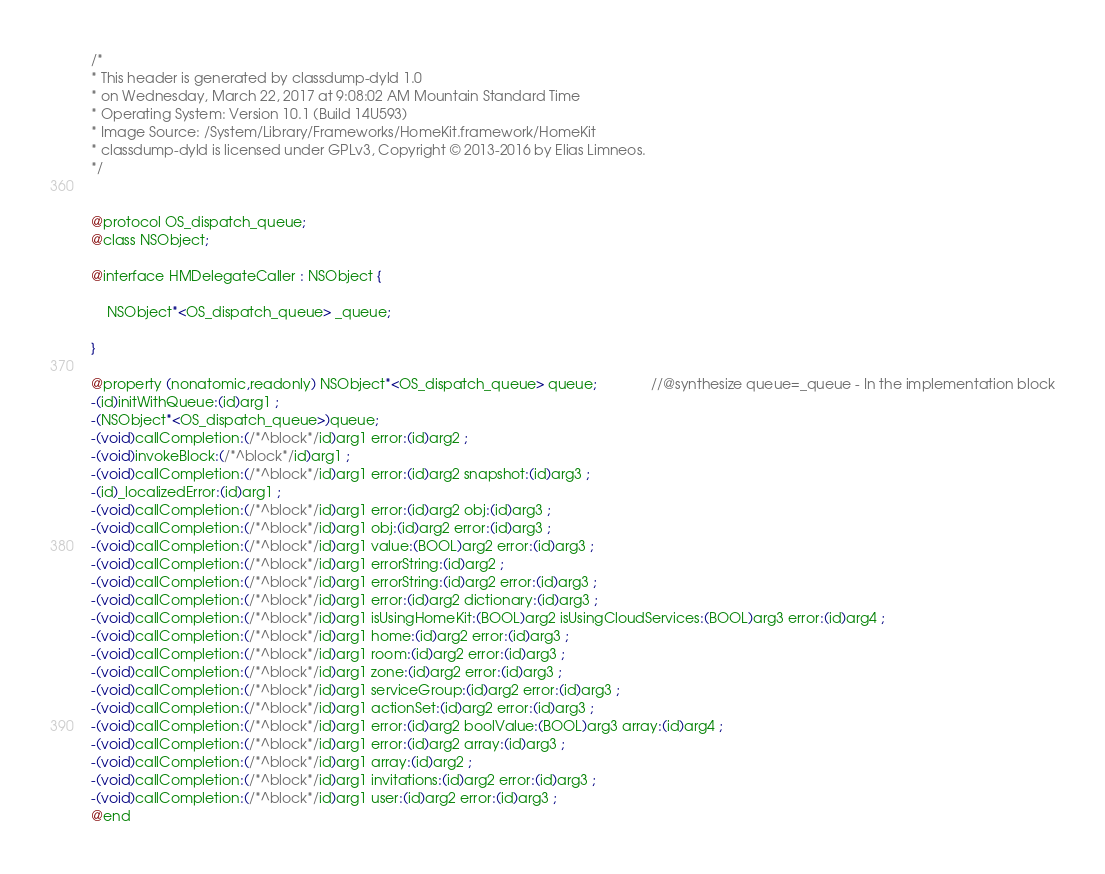<code> <loc_0><loc_0><loc_500><loc_500><_C_>/*
* This header is generated by classdump-dyld 1.0
* on Wednesday, March 22, 2017 at 9:08:02 AM Mountain Standard Time
* Operating System: Version 10.1 (Build 14U593)
* Image Source: /System/Library/Frameworks/HomeKit.framework/HomeKit
* classdump-dyld is licensed under GPLv3, Copyright © 2013-2016 by Elias Limneos.
*/


@protocol OS_dispatch_queue;
@class NSObject;

@interface HMDelegateCaller : NSObject {

	NSObject*<OS_dispatch_queue> _queue;

}

@property (nonatomic,readonly) NSObject*<OS_dispatch_queue> queue;              //@synthesize queue=_queue - In the implementation block
-(id)initWithQueue:(id)arg1 ;
-(NSObject*<OS_dispatch_queue>)queue;
-(void)callCompletion:(/*^block*/id)arg1 error:(id)arg2 ;
-(void)invokeBlock:(/*^block*/id)arg1 ;
-(void)callCompletion:(/*^block*/id)arg1 error:(id)arg2 snapshot:(id)arg3 ;
-(id)_localizedError:(id)arg1 ;
-(void)callCompletion:(/*^block*/id)arg1 error:(id)arg2 obj:(id)arg3 ;
-(void)callCompletion:(/*^block*/id)arg1 obj:(id)arg2 error:(id)arg3 ;
-(void)callCompletion:(/*^block*/id)arg1 value:(BOOL)arg2 error:(id)arg3 ;
-(void)callCompletion:(/*^block*/id)arg1 errorString:(id)arg2 ;
-(void)callCompletion:(/*^block*/id)arg1 errorString:(id)arg2 error:(id)arg3 ;
-(void)callCompletion:(/*^block*/id)arg1 error:(id)arg2 dictionary:(id)arg3 ;
-(void)callCompletion:(/*^block*/id)arg1 isUsingHomeKit:(BOOL)arg2 isUsingCloudServices:(BOOL)arg3 error:(id)arg4 ;
-(void)callCompletion:(/*^block*/id)arg1 home:(id)arg2 error:(id)arg3 ;
-(void)callCompletion:(/*^block*/id)arg1 room:(id)arg2 error:(id)arg3 ;
-(void)callCompletion:(/*^block*/id)arg1 zone:(id)arg2 error:(id)arg3 ;
-(void)callCompletion:(/*^block*/id)arg1 serviceGroup:(id)arg2 error:(id)arg3 ;
-(void)callCompletion:(/*^block*/id)arg1 actionSet:(id)arg2 error:(id)arg3 ;
-(void)callCompletion:(/*^block*/id)arg1 error:(id)arg2 boolValue:(BOOL)arg3 array:(id)arg4 ;
-(void)callCompletion:(/*^block*/id)arg1 error:(id)arg2 array:(id)arg3 ;
-(void)callCompletion:(/*^block*/id)arg1 array:(id)arg2 ;
-(void)callCompletion:(/*^block*/id)arg1 invitations:(id)arg2 error:(id)arg3 ;
-(void)callCompletion:(/*^block*/id)arg1 user:(id)arg2 error:(id)arg3 ;
@end

</code> 